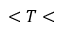<formula> <loc_0><loc_0><loc_500><loc_500>< T <</formula> 